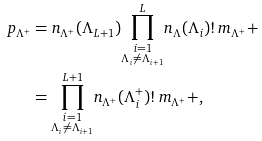Convert formula to latex. <formula><loc_0><loc_0><loc_500><loc_500>p _ { \Lambda ^ { + } } & = n _ { \Lambda ^ { + } } ( \Lambda _ { L + 1 } ) { \prod _ { \substack { i = 1 \\ \Lambda _ { i } \neq \Lambda _ { i + 1 } } } ^ { L } } n _ { \Lambda } ( \Lambda _ { i } ) ! \, m _ { \Lambda ^ { + } } + \\ & = { \prod _ { \substack { i = 1 \\ \Lambda _ { i } \neq \Lambda _ { i + 1 } } } ^ { L + 1 } } n _ { \Lambda ^ { + } } ( \Lambda ^ { + } _ { i } ) ! \, m _ { \Lambda ^ { + } } + ,</formula> 